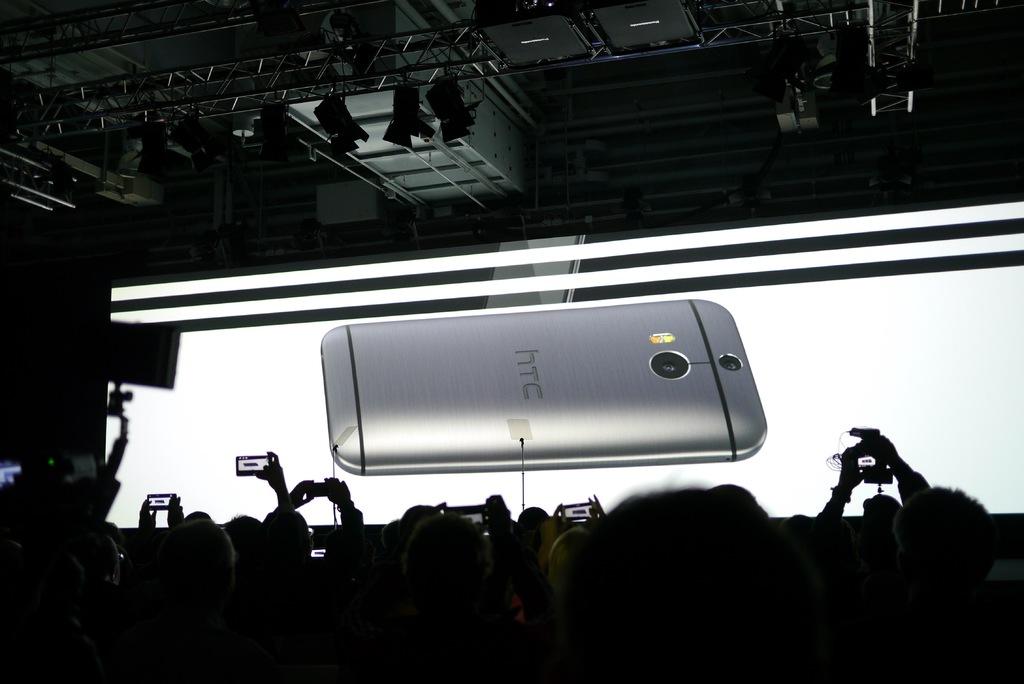What brand of phone is this?
Your answer should be compact. Htc. 